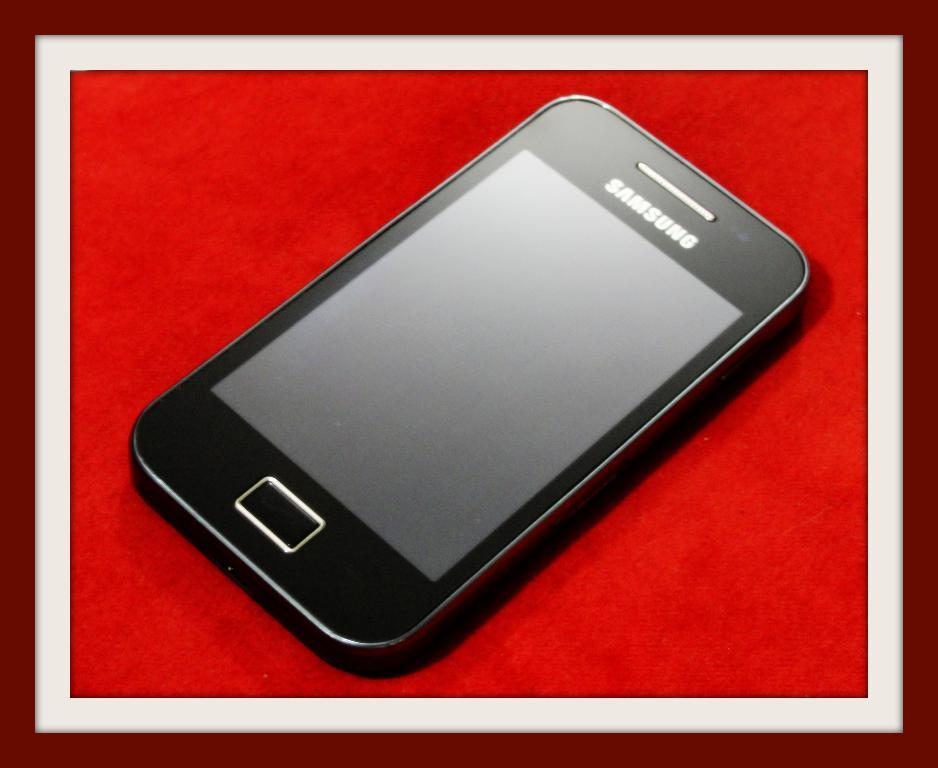<image>
Relay a brief, clear account of the picture shown. a black samsung phone with the screen off and a rectangular button at the bottom 